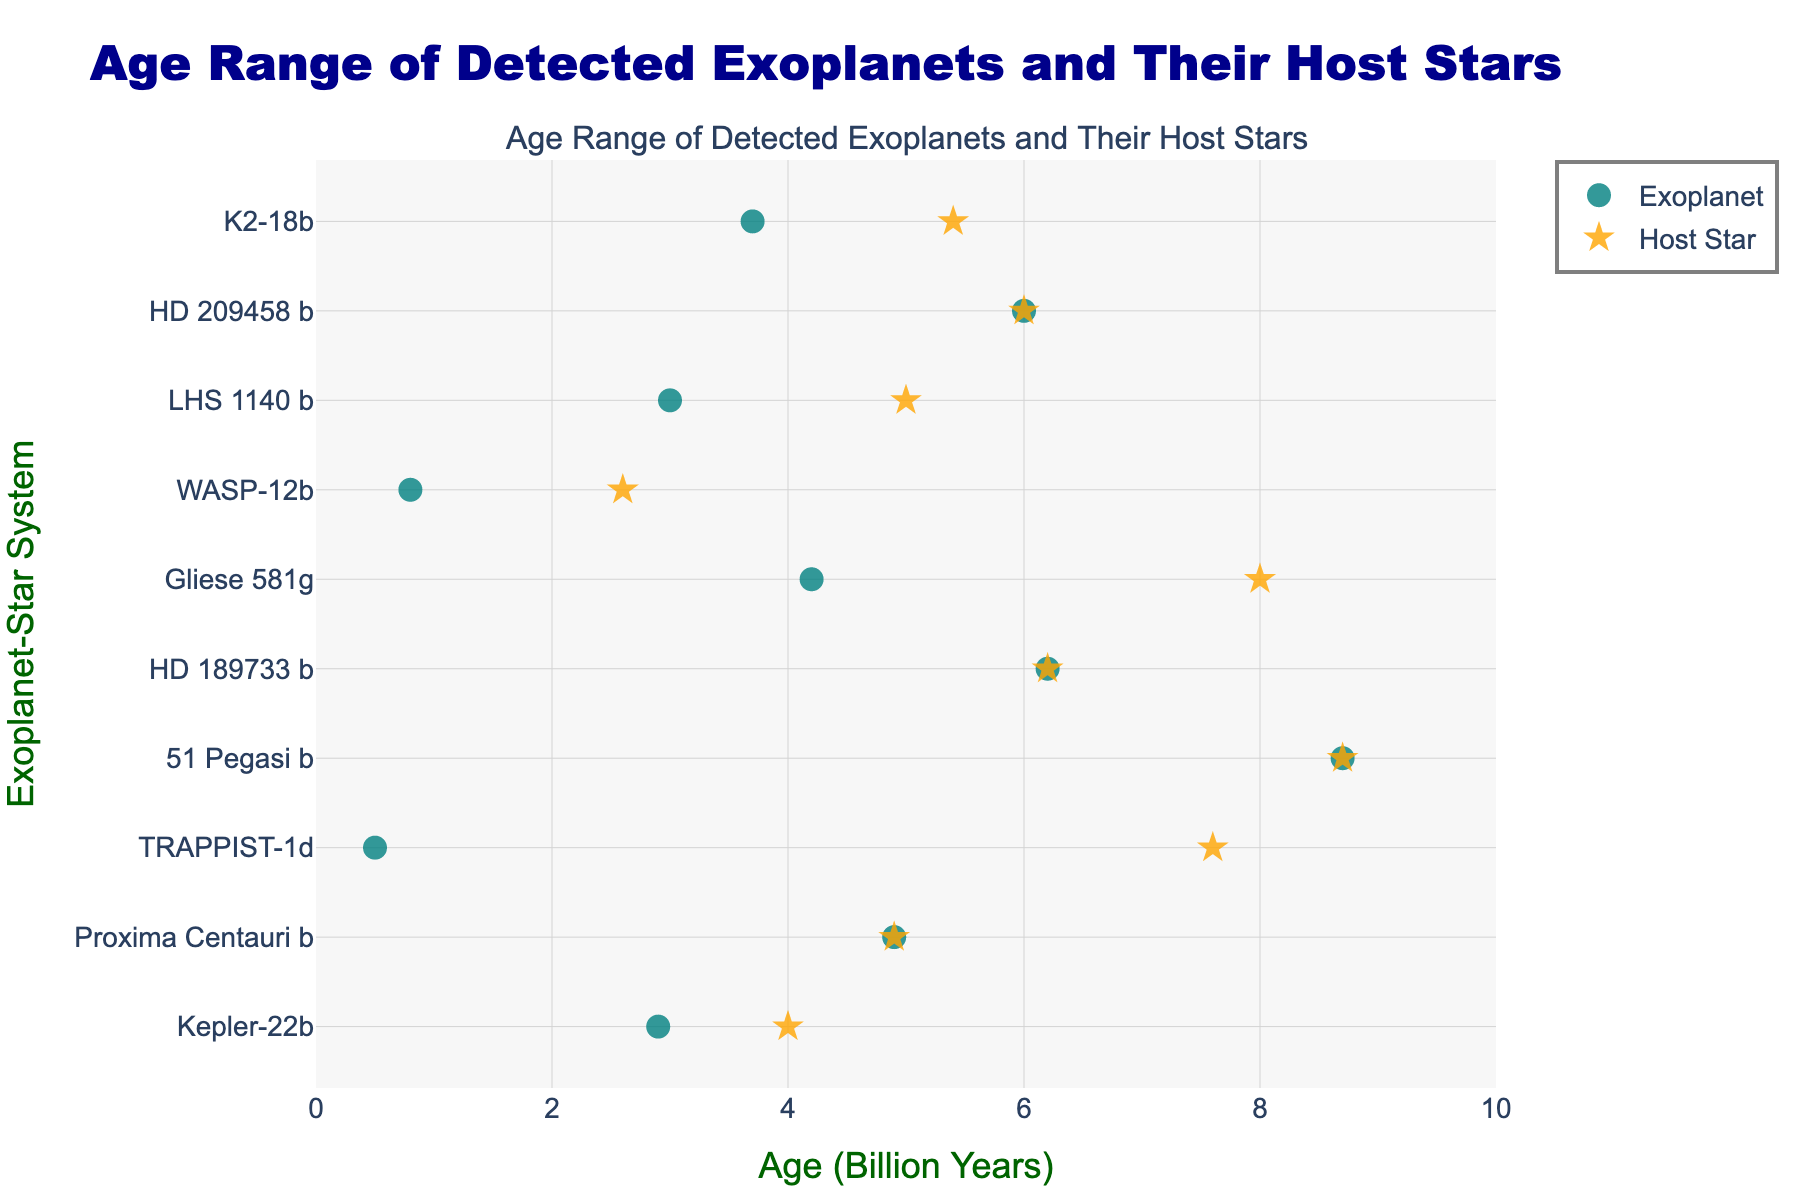How old is Proxima Centauri b? Locate Proxima Centauri b on the y-axis and see where the dot representing its age lies on the x-axis. It is marked at 4.9 billion years.
Answer: 4.9 billion years What color represents the exoplanets? Observe the color of the markers labeled as exoplanets. The exoplanets are represented by teal-colored circles.
Answer: Teal Which exoplanet-star system has the oldest host star? Compare the x-axis values for the star ages and find the highest value. TRAPPIST-1 has the oldest host star at 7.6 billion years.
Answer: TRAPPIST-1 How much older is the star HD 209458 compared to the exoplanet HD 209458 b? Subtract the age of HD 209458 b (6.0 billion years) from the age of HD 209458 (6.0 billion years). The difference is 0 years.
Answer: 0 years Which star-system has the largest age difference between the star and its exoplanet? Calculate the differences for each system and identify the maximum. TRAPPIST-1 has the largest age difference: 7.6 billion years - 0.5 billion years = 7.1 billion years.
Answer: TRAPPIST-1 What is the median age of the exoplanets? Order the exoplanet ages and find the middle value: {0.5, 0.8, 2.9, 3.0, 3.7, 4.2, 4.9, 6.0, 6.2, 8.7} billion years. The median is the average of the 5th and 6th values: (3.7 + 4.2)/2 = 3.95 billion years.
Answer: 3.95 billion years Does any star have the same age as its exoplanet? Look at the data points for stars and exoplanets and check for overlapping ages. Proxima Centauri and its exoplanet Proxima Centauri b both are 4.9 billion years old.
Answer: Yes How many exoplanet-star systems have exoplanets younger than 1 billion years? Count the dots representing exoplanet ages below 1 billion years: TRAPPIST-1d, WASP-12b. There are 2 such systems.
Answer: 2 systems What is the average age of the host stars? Add the star ages and divide by the number of systems: (4 + 4.9 + 7.6 + 8.7 + 6.2 + 8 + 2.6 + 5 + 6 + 5.4) / 10 = 5.98 billion years.
Answer: 5.98 billion years Is the age range of the stars broader or narrower than the age range of the exoplanets? Compare the age ranges: Stars range from 2.6 to 8.7 billion years (6.1 billion years), while exoplanets range from 0.5 to 8.7 billion years (8.2 billion years).
Answer: Broader 